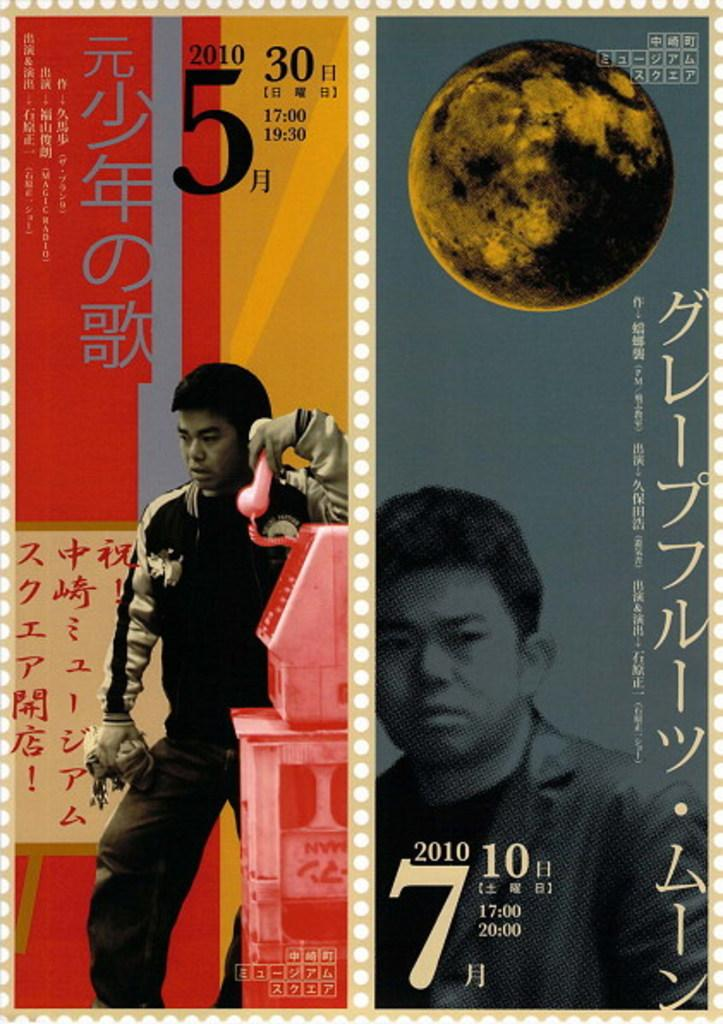Provide a one-sentence caption for the provided image. A stamp featuring Asian writing and a young man pictured. 